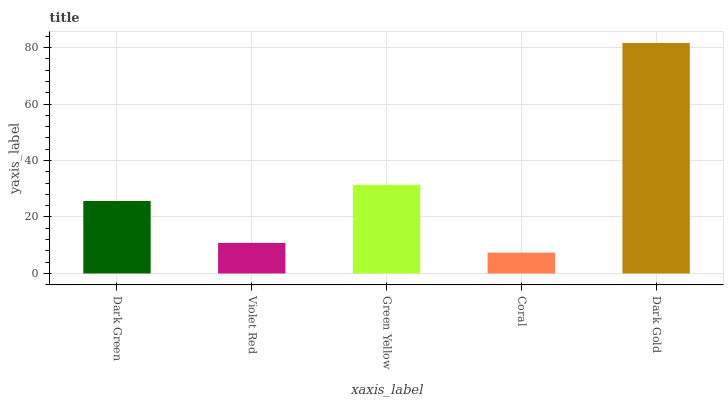Is Coral the minimum?
Answer yes or no. Yes. Is Dark Gold the maximum?
Answer yes or no. Yes. Is Violet Red the minimum?
Answer yes or no. No. Is Violet Red the maximum?
Answer yes or no. No. Is Dark Green greater than Violet Red?
Answer yes or no. Yes. Is Violet Red less than Dark Green?
Answer yes or no. Yes. Is Violet Red greater than Dark Green?
Answer yes or no. No. Is Dark Green less than Violet Red?
Answer yes or no. No. Is Dark Green the high median?
Answer yes or no. Yes. Is Dark Green the low median?
Answer yes or no. Yes. Is Violet Red the high median?
Answer yes or no. No. Is Violet Red the low median?
Answer yes or no. No. 